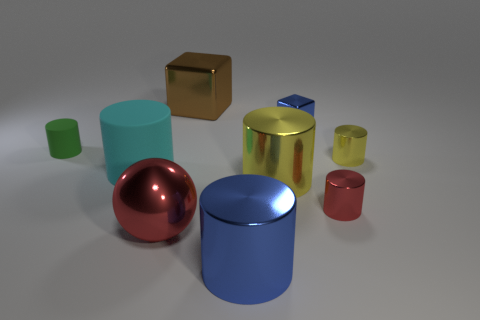How many other objects are there of the same shape as the large blue object?
Your answer should be compact. 5. Are there any gray spheres made of the same material as the large cyan cylinder?
Your response must be concise. No. Is the red object that is right of the big blue metallic thing made of the same material as the large thing behind the tiny green cylinder?
Make the answer very short. Yes. What number of big blue cylinders are there?
Your answer should be compact. 1. The yellow thing that is to the right of the large yellow cylinder has what shape?
Provide a short and direct response. Cylinder. How many other things are there of the same size as the brown metal cube?
Your answer should be compact. 4. There is a blue object that is behind the big red object; does it have the same shape as the small yellow shiny object that is right of the cyan matte cylinder?
Make the answer very short. No. There is a large yellow shiny cylinder; how many yellow objects are in front of it?
Provide a short and direct response. 0. The rubber object in front of the tiny green thing is what color?
Keep it short and to the point. Cyan. There is another matte thing that is the same shape as the tiny matte object; what color is it?
Your answer should be very brief. Cyan. 